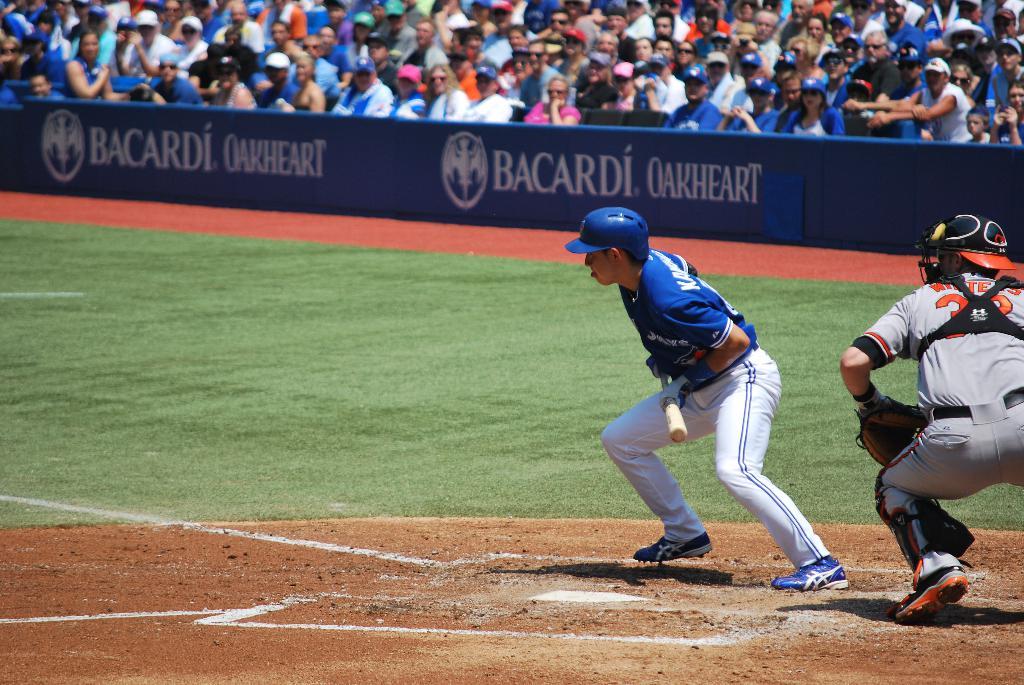What liquor brand sponsors this ball park?
Your answer should be compact. Bacardi. What bacardi product is being advertised?
Provide a succinct answer. Oakheart. 